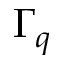Convert formula to latex. <formula><loc_0><loc_0><loc_500><loc_500>\Gamma _ { q }</formula> 